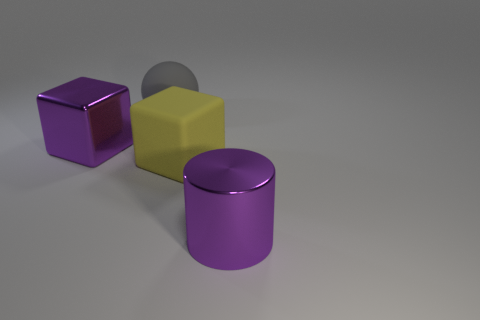How do the textures of the different objects in the image compare? The image presents objects with varying textures. The purple blocks appear to have a smooth but matte rubber finish that diffuses light softly. In contrast, the purple metallic cylinder has a more reflective, shiny surface consistent with metal, which creates highlights and sharper reflections. 